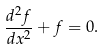Convert formula to latex. <formula><loc_0><loc_0><loc_500><loc_500>\frac { d ^ { 2 } f } { d x ^ { 2 } } + f = 0 .</formula> 